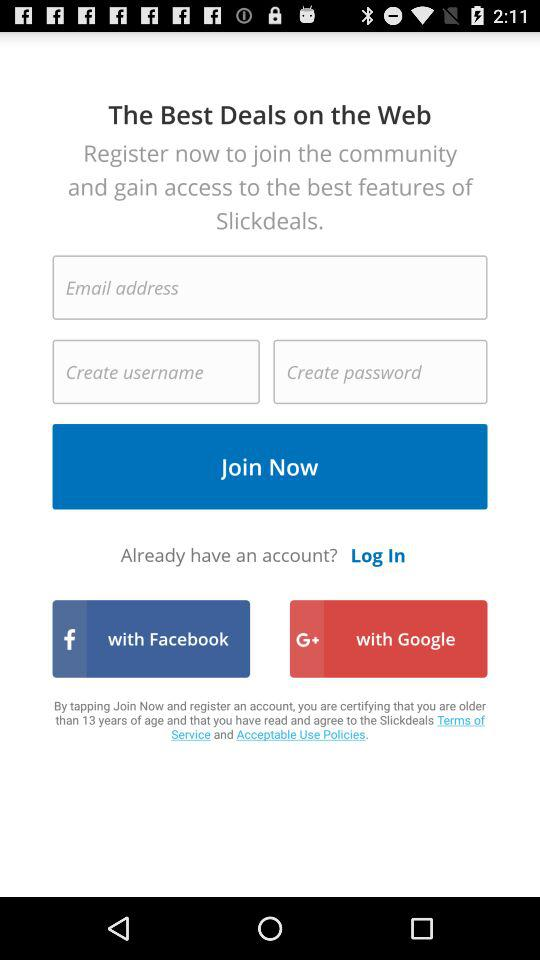Through what applications can we log in with? You can log in "with Facebook" and "with Google". 